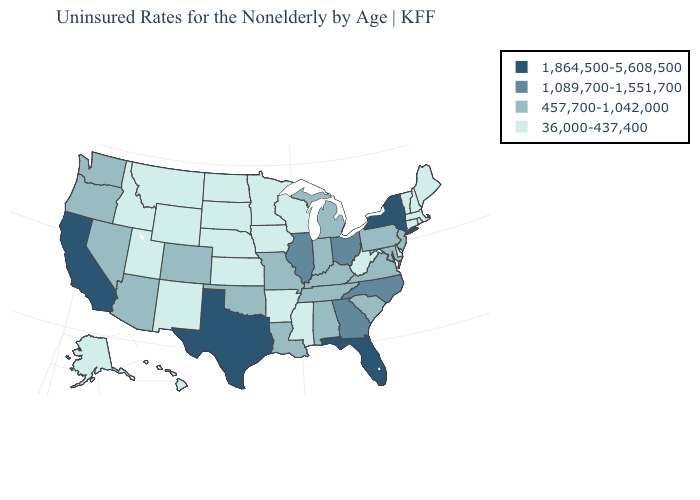Does California have the highest value in the West?
Give a very brief answer. Yes. What is the value of Oklahoma?
Short answer required. 457,700-1,042,000. Does Utah have a higher value than Iowa?
Be succinct. No. Does Minnesota have the same value as Iowa?
Give a very brief answer. Yes. Is the legend a continuous bar?
Write a very short answer. No. Does California have the highest value in the USA?
Give a very brief answer. Yes. Does Texas have the highest value in the USA?
Quick response, please. Yes. Does New Jersey have the lowest value in the Northeast?
Write a very short answer. No. How many symbols are there in the legend?
Quick response, please. 4. Which states have the highest value in the USA?
Quick response, please. California, Florida, New York, Texas. Name the states that have a value in the range 1,089,700-1,551,700?
Be succinct. Georgia, Illinois, North Carolina, Ohio. Does Colorado have the lowest value in the West?
Quick response, please. No. Which states hav the highest value in the Northeast?
Short answer required. New York. Does South Carolina have the lowest value in the South?
Be succinct. No. What is the value of New Hampshire?
Give a very brief answer. 36,000-437,400. 